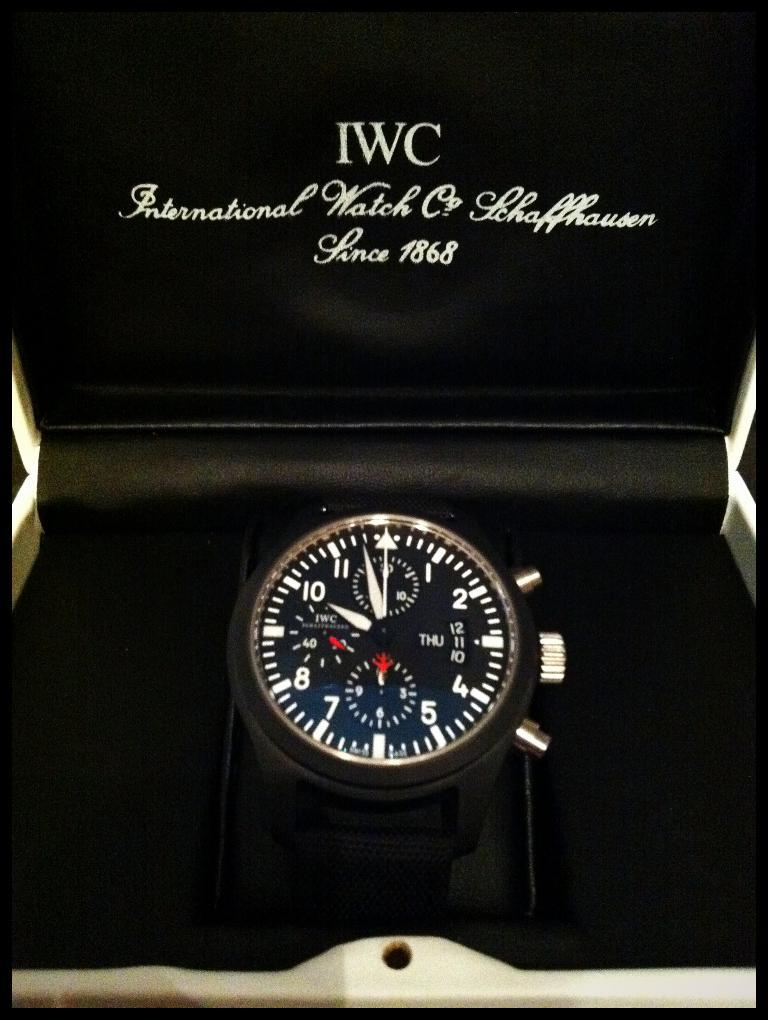Provide a one-sentence caption for the provided image. An IWC watch on display in a black lined box. 